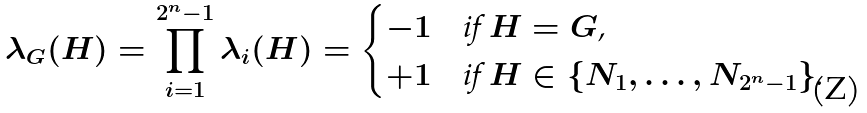<formula> <loc_0><loc_0><loc_500><loc_500>\lambda _ { G } ( H ) = \prod _ { i = 1 } ^ { 2 ^ { n } - 1 } \lambda _ { i } ( H ) = \begin{cases} - 1 & \text {if $H = G$,} \\ + 1 & \text {if $H \in \{N_{1}, \dots, N_{2^{n}-1}\}$.} \end{cases}</formula> 